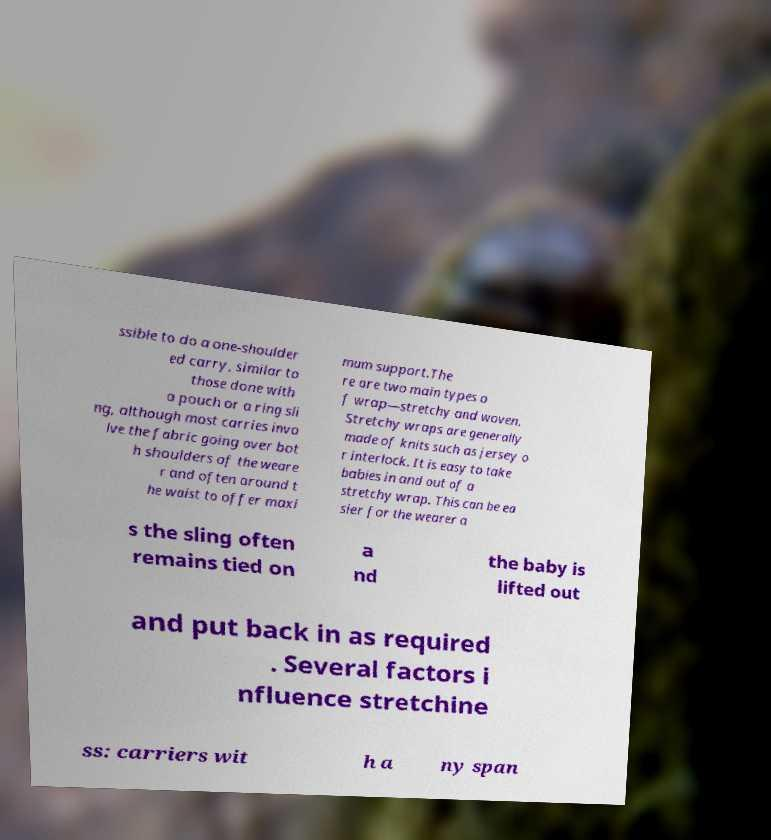For documentation purposes, I need the text within this image transcribed. Could you provide that? ssible to do a one-shoulder ed carry, similar to those done with a pouch or a ring sli ng, although most carries invo lve the fabric going over bot h shoulders of the weare r and often around t he waist to offer maxi mum support.The re are two main types o f wrap—stretchy and woven. Stretchy wraps are generally made of knits such as jersey o r interlock. It is easy to take babies in and out of a stretchy wrap. This can be ea sier for the wearer a s the sling often remains tied on a nd the baby is lifted out and put back in as required . Several factors i nfluence stretchine ss: carriers wit h a ny span 